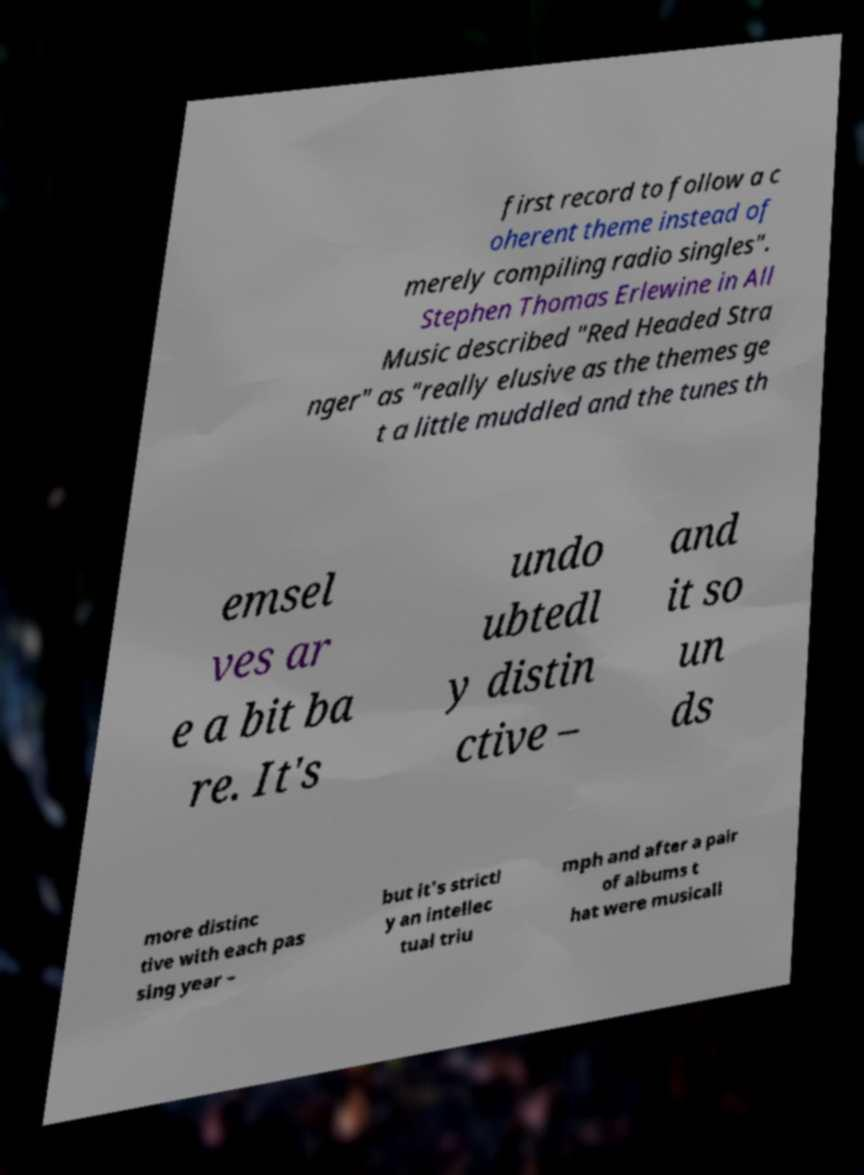For documentation purposes, I need the text within this image transcribed. Could you provide that? first record to follow a c oherent theme instead of merely compiling radio singles". Stephen Thomas Erlewine in All Music described "Red Headed Stra nger" as "really elusive as the themes ge t a little muddled and the tunes th emsel ves ar e a bit ba re. It's undo ubtedl y distin ctive – and it so un ds more distinc tive with each pas sing year – but it's strictl y an intellec tual triu mph and after a pair of albums t hat were musicall 